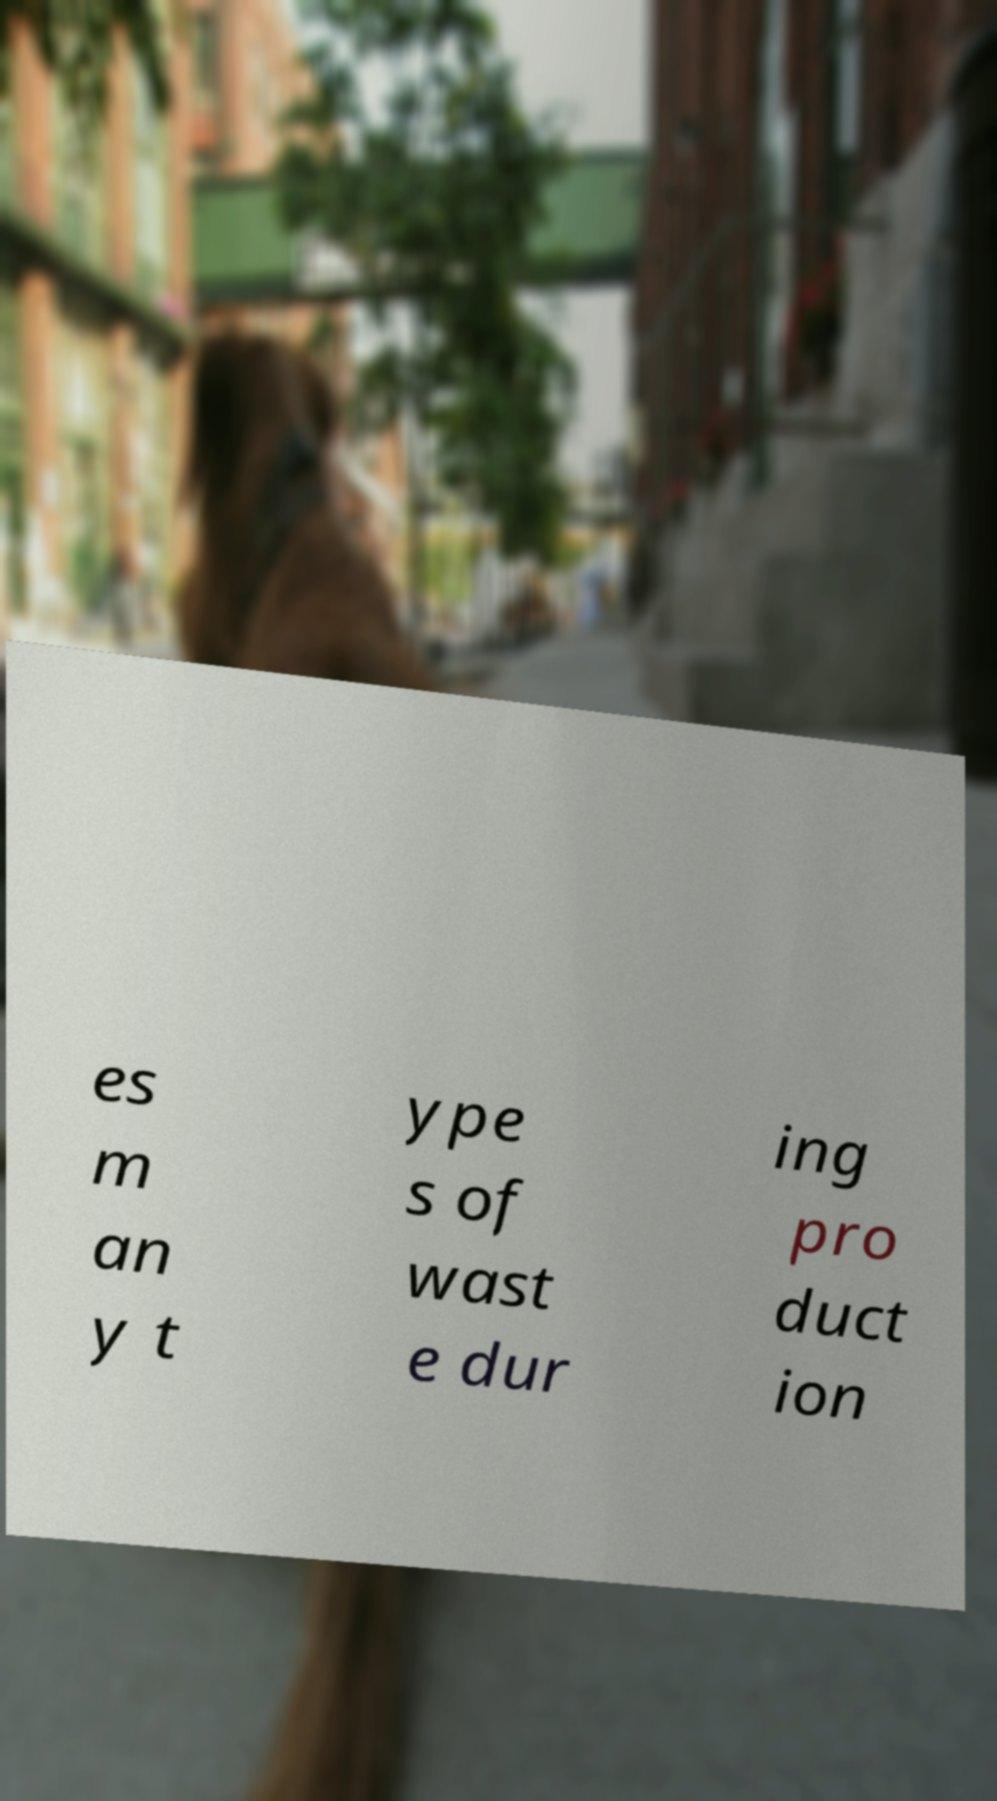Could you assist in decoding the text presented in this image and type it out clearly? es m an y t ype s of wast e dur ing pro duct ion 